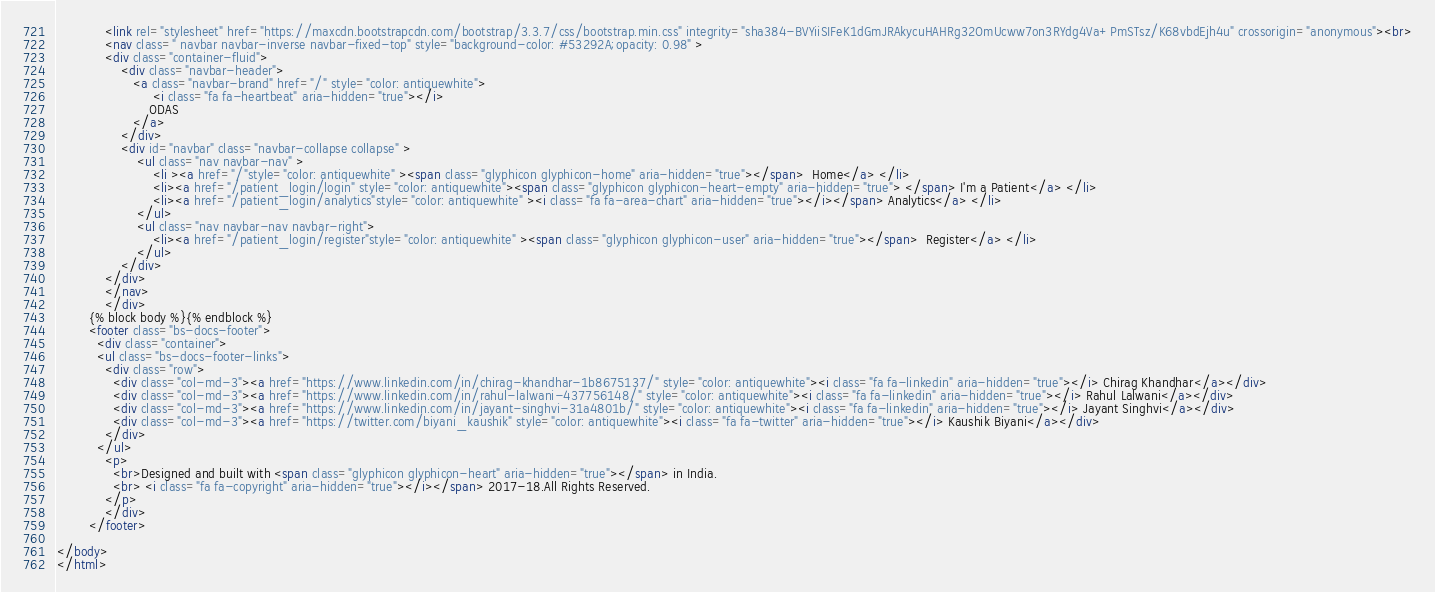<code> <loc_0><loc_0><loc_500><loc_500><_HTML_>            <link rel="stylesheet" href="https://maxcdn.bootstrapcdn.com/bootstrap/3.3.7/css/bootstrap.min.css" integrity="sha384-BVYiiSIFeK1dGmJRAkycuHAHRg32OmUcww7on3RYdg4Va+PmSTsz/K68vbdEjh4u" crossorigin="anonymous"><br>
            <nav class=" navbar navbar-inverse navbar-fixed-top" style="background-color: #53292A;opacity: 0.98" >
            <div class="container-fluid">
                <div class="navbar-header">
                   <a class="navbar-brand" href="/" style="color: antiquewhite">
                        <i class="fa fa-heartbeat" aria-hidden="true"></i>
                       ODAS
                   </a>
                </div>
                <div id="navbar" class="navbar-collapse collapse" >
                    <ul class="nav navbar-nav" >
                        <li ><a href="/"style="color: antiquewhite" ><span class="glyphicon glyphicon-home" aria-hidden="true"></span>  Home</a> </li>
                        <li><a href="/patient_login/login" style="color: antiquewhite"><span class="glyphicon glyphicon-heart-empty" aria-hidden="true"> </span> I'm a Patient</a> </li>
                        <li><a href="/patient_login/analytics"style="color: antiquewhite" ><i class="fa fa-area-chart" aria-hidden="true"></i></span> Analytics</a> </li>
                    </ul>
                    <ul class="nav navbar-nav navbar-right">
                        <li><a href="/patient_login/register"style="color: antiquewhite" ><span class="glyphicon glyphicon-user" aria-hidden="true"></span>  Register</a> </li>
                    </ul>
                </div>
            </div>
            </nav>
            </div>
        {% block body %}{% endblock %}
        <footer class="bs-docs-footer">
          <div class="container">
          <ul class="bs-docs-footer-links">
            <div class="row">
              <div class="col-md-3"><a href="https://www.linkedin.com/in/chirag-khandhar-1b8675137/" style="color: antiquewhite"><i class="fa fa-linkedin" aria-hidden="true"></i> Chirag Khandhar</a></div>
              <div class="col-md-3"><a href="https://www.linkedin.com/in/rahul-lalwani-437756148/" style="color: antiquewhite"><i class="fa fa-linkedin" aria-hidden="true"></i> Rahul Lalwani</a></div>
              <div class="col-md-3"><a href="https://www.linkedin.com/in/jayant-singhvi-31a4801b/" style="color: antiquewhite"><i class="fa fa-linkedin" aria-hidden="true"></i> Jayant Singhvi</a></div>
              <div class="col-md-3"><a href="https://twitter.com/biyani_kaushik" style="color: antiquewhite"><i class="fa fa-twitter" aria-hidden="true"></i> Kaushik Biyani</a></div>
            </div>
          </ul>
            <p>
              <br>Designed and built with <span class="glyphicon glyphicon-heart" aria-hidden="true"></span> in India.
              <br> <i class="fa fa-copyright" aria-hidden="true"></i></span> 2017-18.All Rights Reserved.
            </p>
            </div>
        </footer>

</body>
</html>
</code> 